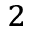<formula> <loc_0><loc_0><loc_500><loc_500>^ { 2 }</formula> 